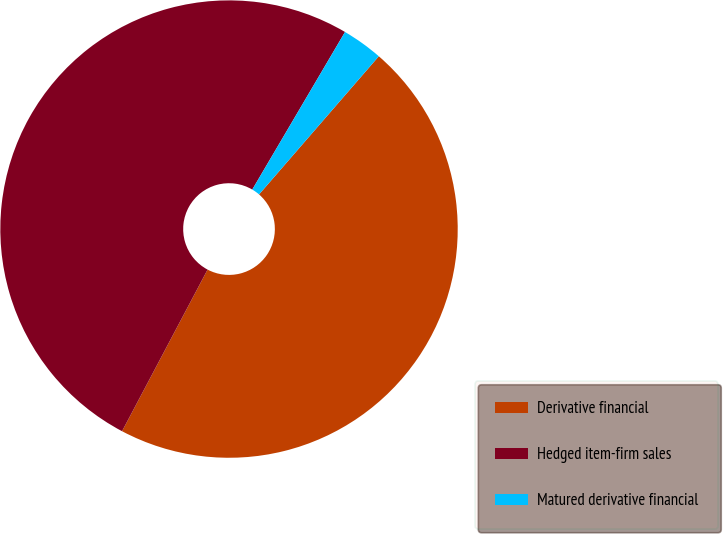Convert chart. <chart><loc_0><loc_0><loc_500><loc_500><pie_chart><fcel>Derivative financial<fcel>Hedged item-firm sales<fcel>Matured derivative financial<nl><fcel>46.38%<fcel>50.72%<fcel>2.9%<nl></chart> 